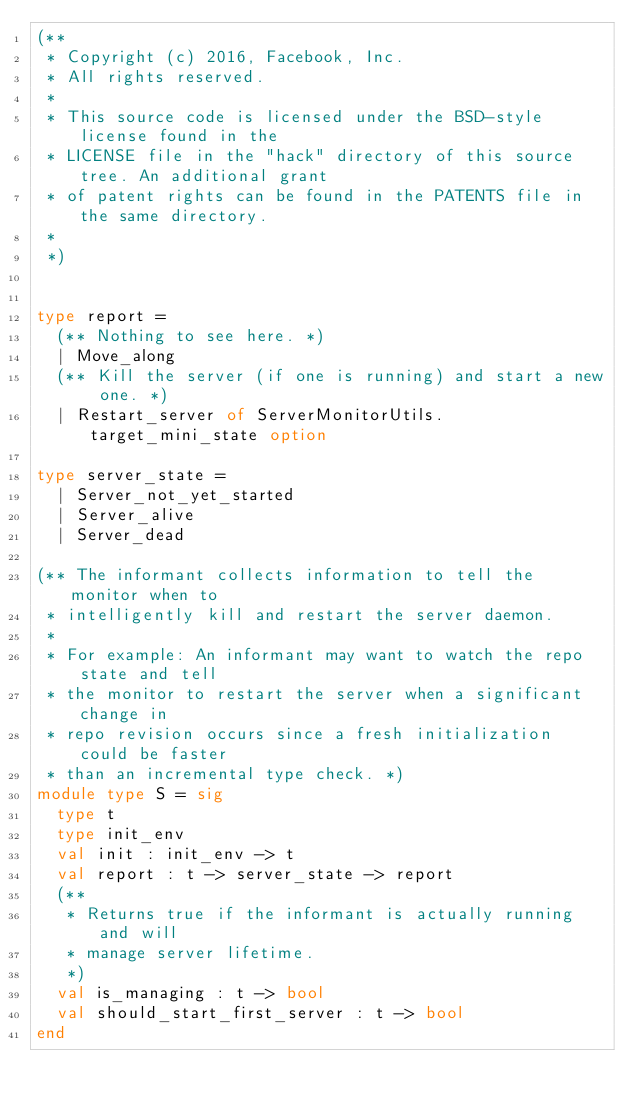<code> <loc_0><loc_0><loc_500><loc_500><_OCaml_>(**
 * Copyright (c) 2016, Facebook, Inc.
 * All rights reserved.
 *
 * This source code is licensed under the BSD-style license found in the
 * LICENSE file in the "hack" directory of this source tree. An additional grant
 * of patent rights can be found in the PATENTS file in the same directory.
 *
 *)


type report =
  (** Nothing to see here. *)
  | Move_along
  (** Kill the server (if one is running) and start a new one. *)
  | Restart_server of ServerMonitorUtils.target_mini_state option

type server_state =
  | Server_not_yet_started
  | Server_alive
  | Server_dead

(** The informant collects information to tell the monitor when to
 * intelligently kill and restart the server daemon.
 *
 * For example: An informant may want to watch the repo state and tell
 * the monitor to restart the server when a significant change in
 * repo revision occurs since a fresh initialization could be faster
 * than an incremental type check. *)
module type S = sig
  type t
  type init_env
  val init : init_env -> t
  val report : t -> server_state -> report
  (**
   * Returns true if the informant is actually running and will
   * manage server lifetime.
   *)
  val is_managing : t -> bool
  val should_start_first_server : t -> bool
end
</code> 